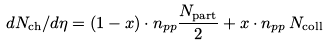<formula> <loc_0><loc_0><loc_500><loc_500>d N _ { \text {ch} } / d \eta = ( 1 - x ) \cdot n _ { p p } \frac { N _ { \text {part} } } { 2 } + x \cdot n _ { p p } \, N _ { \text {coll} }</formula> 